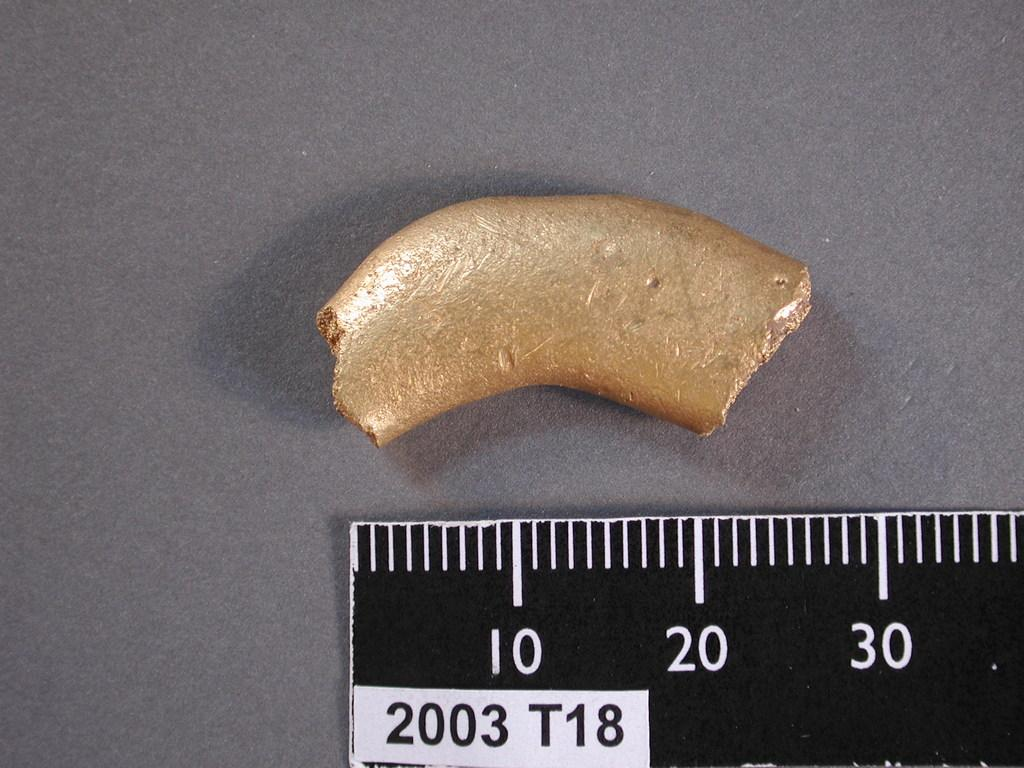<image>
Describe the image concisely. A black and white ruler with 2003 T18 on it. 